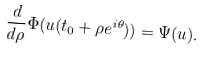<formula> <loc_0><loc_0><loc_500><loc_500>\frac { d } { d \rho } \Phi ( u ( t _ { 0 } + \rho e ^ { i \theta } ) ) = \Psi ( u ) .</formula> 